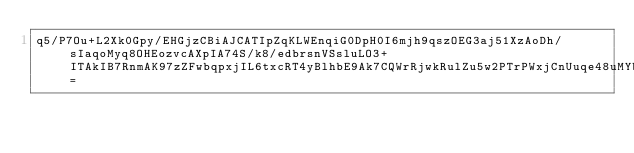<code> <loc_0><loc_0><loc_500><loc_500><_SML_>q5/P7Ou+L2Xk0Gpy/EHGjzCBiAJCATIpZqKLWEnqiG0DpH0I6mjh9qszOEG3aj51XzAoDh/sIaqoMyq8OHEozvcAXpIA74S/k8/edbrsnVSsluLO3+ITAkIB7RnmAK97zZFwbqpxjIL6txcRT4yBlhbE9Ak7CQWrRjwkRulZu5w2PTrPWxjCnUuqe48uMYbfn5z4UFXLIGwHibI=</code> 